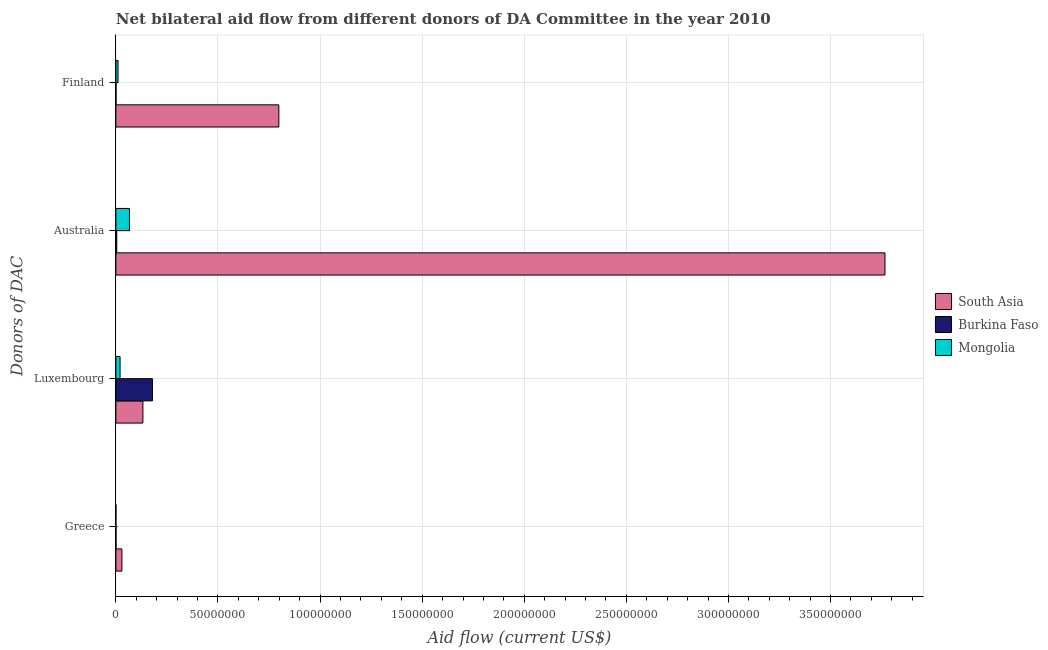How many groups of bars are there?
Provide a succinct answer. 4. Are the number of bars per tick equal to the number of legend labels?
Your answer should be very brief. Yes. How many bars are there on the 4th tick from the top?
Ensure brevity in your answer.  3. How many bars are there on the 1st tick from the bottom?
Keep it short and to the point. 3. What is the label of the 1st group of bars from the top?
Offer a terse response. Finland. What is the amount of aid given by australia in Mongolia?
Provide a succinct answer. 6.64e+06. Across all countries, what is the maximum amount of aid given by finland?
Your answer should be very brief. 7.98e+07. Across all countries, what is the minimum amount of aid given by finland?
Give a very brief answer. 8.00e+04. In which country was the amount of aid given by finland minimum?
Make the answer very short. Burkina Faso. What is the total amount of aid given by greece in the graph?
Make the answer very short. 3.04e+06. What is the difference between the amount of aid given by greece in Burkina Faso and that in Mongolia?
Keep it short and to the point. 6.00e+04. What is the difference between the amount of aid given by finland in Mongolia and the amount of aid given by australia in Burkina Faso?
Provide a succinct answer. 6.40e+05. What is the average amount of aid given by greece per country?
Provide a short and direct response. 1.01e+06. What is the difference between the amount of aid given by greece and amount of aid given by finland in Mongolia?
Make the answer very short. -1.05e+06. What is the ratio of the amount of aid given by luxembourg in Burkina Faso to that in Mongolia?
Provide a short and direct response. 8.73. What is the difference between the highest and the second highest amount of aid given by finland?
Your answer should be very brief. 7.88e+07. What is the difference between the highest and the lowest amount of aid given by greece?
Provide a short and direct response. 2.95e+06. Is the sum of the amount of aid given by finland in Mongolia and South Asia greater than the maximum amount of aid given by greece across all countries?
Your answer should be very brief. Yes. What does the 2nd bar from the top in Greece represents?
Make the answer very short. Burkina Faso. What does the 3rd bar from the bottom in Finland represents?
Give a very brief answer. Mongolia. Are all the bars in the graph horizontal?
Your answer should be compact. Yes. How many countries are there in the graph?
Your answer should be very brief. 3. What is the difference between two consecutive major ticks on the X-axis?
Your answer should be compact. 5.00e+07. Does the graph contain grids?
Keep it short and to the point. Yes. Where does the legend appear in the graph?
Ensure brevity in your answer.  Center right. How many legend labels are there?
Give a very brief answer. 3. What is the title of the graph?
Your answer should be very brief. Net bilateral aid flow from different donors of DA Committee in the year 2010. Does "Lower middle income" appear as one of the legend labels in the graph?
Offer a terse response. No. What is the label or title of the Y-axis?
Your answer should be compact. Donors of DAC. What is the Aid flow (current US$) of South Asia in Greece?
Your response must be concise. 2.96e+06. What is the Aid flow (current US$) in Burkina Faso in Greece?
Provide a succinct answer. 7.00e+04. What is the Aid flow (current US$) of Mongolia in Greece?
Offer a very short reply. 10000. What is the Aid flow (current US$) of South Asia in Luxembourg?
Keep it short and to the point. 1.32e+07. What is the Aid flow (current US$) of Burkina Faso in Luxembourg?
Make the answer very short. 1.79e+07. What is the Aid flow (current US$) in Mongolia in Luxembourg?
Make the answer very short. 2.05e+06. What is the Aid flow (current US$) of South Asia in Australia?
Make the answer very short. 3.77e+08. What is the Aid flow (current US$) in Burkina Faso in Australia?
Offer a very short reply. 4.20e+05. What is the Aid flow (current US$) in Mongolia in Australia?
Keep it short and to the point. 6.64e+06. What is the Aid flow (current US$) of South Asia in Finland?
Give a very brief answer. 7.98e+07. What is the Aid flow (current US$) in Mongolia in Finland?
Keep it short and to the point. 1.06e+06. Across all Donors of DAC, what is the maximum Aid flow (current US$) of South Asia?
Offer a very short reply. 3.77e+08. Across all Donors of DAC, what is the maximum Aid flow (current US$) in Burkina Faso?
Keep it short and to the point. 1.79e+07. Across all Donors of DAC, what is the maximum Aid flow (current US$) in Mongolia?
Your answer should be very brief. 6.64e+06. Across all Donors of DAC, what is the minimum Aid flow (current US$) in South Asia?
Your answer should be compact. 2.96e+06. Across all Donors of DAC, what is the minimum Aid flow (current US$) in Mongolia?
Provide a succinct answer. 10000. What is the total Aid flow (current US$) in South Asia in the graph?
Offer a terse response. 4.73e+08. What is the total Aid flow (current US$) in Burkina Faso in the graph?
Your answer should be compact. 1.85e+07. What is the total Aid flow (current US$) in Mongolia in the graph?
Your response must be concise. 9.76e+06. What is the difference between the Aid flow (current US$) of South Asia in Greece and that in Luxembourg?
Make the answer very short. -1.03e+07. What is the difference between the Aid flow (current US$) in Burkina Faso in Greece and that in Luxembourg?
Give a very brief answer. -1.78e+07. What is the difference between the Aid flow (current US$) in Mongolia in Greece and that in Luxembourg?
Your answer should be very brief. -2.04e+06. What is the difference between the Aid flow (current US$) of South Asia in Greece and that in Australia?
Give a very brief answer. -3.74e+08. What is the difference between the Aid flow (current US$) in Burkina Faso in Greece and that in Australia?
Provide a succinct answer. -3.50e+05. What is the difference between the Aid flow (current US$) in Mongolia in Greece and that in Australia?
Your answer should be very brief. -6.63e+06. What is the difference between the Aid flow (current US$) of South Asia in Greece and that in Finland?
Keep it short and to the point. -7.68e+07. What is the difference between the Aid flow (current US$) of Mongolia in Greece and that in Finland?
Your answer should be compact. -1.05e+06. What is the difference between the Aid flow (current US$) of South Asia in Luxembourg and that in Australia?
Provide a succinct answer. -3.63e+08. What is the difference between the Aid flow (current US$) of Burkina Faso in Luxembourg and that in Australia?
Offer a terse response. 1.75e+07. What is the difference between the Aid flow (current US$) in Mongolia in Luxembourg and that in Australia?
Ensure brevity in your answer.  -4.59e+06. What is the difference between the Aid flow (current US$) of South Asia in Luxembourg and that in Finland?
Give a very brief answer. -6.66e+07. What is the difference between the Aid flow (current US$) in Burkina Faso in Luxembourg and that in Finland?
Offer a terse response. 1.78e+07. What is the difference between the Aid flow (current US$) in Mongolia in Luxembourg and that in Finland?
Your answer should be very brief. 9.90e+05. What is the difference between the Aid flow (current US$) in South Asia in Australia and that in Finland?
Offer a terse response. 2.97e+08. What is the difference between the Aid flow (current US$) in Burkina Faso in Australia and that in Finland?
Keep it short and to the point. 3.40e+05. What is the difference between the Aid flow (current US$) of Mongolia in Australia and that in Finland?
Keep it short and to the point. 5.58e+06. What is the difference between the Aid flow (current US$) in South Asia in Greece and the Aid flow (current US$) in Burkina Faso in Luxembourg?
Keep it short and to the point. -1.49e+07. What is the difference between the Aid flow (current US$) in South Asia in Greece and the Aid flow (current US$) in Mongolia in Luxembourg?
Provide a short and direct response. 9.10e+05. What is the difference between the Aid flow (current US$) of Burkina Faso in Greece and the Aid flow (current US$) of Mongolia in Luxembourg?
Your response must be concise. -1.98e+06. What is the difference between the Aid flow (current US$) of South Asia in Greece and the Aid flow (current US$) of Burkina Faso in Australia?
Your answer should be very brief. 2.54e+06. What is the difference between the Aid flow (current US$) in South Asia in Greece and the Aid flow (current US$) in Mongolia in Australia?
Offer a terse response. -3.68e+06. What is the difference between the Aid flow (current US$) in Burkina Faso in Greece and the Aid flow (current US$) in Mongolia in Australia?
Your response must be concise. -6.57e+06. What is the difference between the Aid flow (current US$) in South Asia in Greece and the Aid flow (current US$) in Burkina Faso in Finland?
Give a very brief answer. 2.88e+06. What is the difference between the Aid flow (current US$) in South Asia in Greece and the Aid flow (current US$) in Mongolia in Finland?
Your answer should be compact. 1.90e+06. What is the difference between the Aid flow (current US$) of Burkina Faso in Greece and the Aid flow (current US$) of Mongolia in Finland?
Make the answer very short. -9.90e+05. What is the difference between the Aid flow (current US$) of South Asia in Luxembourg and the Aid flow (current US$) of Burkina Faso in Australia?
Your answer should be compact. 1.28e+07. What is the difference between the Aid flow (current US$) in South Asia in Luxembourg and the Aid flow (current US$) in Mongolia in Australia?
Your answer should be compact. 6.59e+06. What is the difference between the Aid flow (current US$) in Burkina Faso in Luxembourg and the Aid flow (current US$) in Mongolia in Australia?
Provide a short and direct response. 1.13e+07. What is the difference between the Aid flow (current US$) of South Asia in Luxembourg and the Aid flow (current US$) of Burkina Faso in Finland?
Make the answer very short. 1.32e+07. What is the difference between the Aid flow (current US$) of South Asia in Luxembourg and the Aid flow (current US$) of Mongolia in Finland?
Your answer should be very brief. 1.22e+07. What is the difference between the Aid flow (current US$) in Burkina Faso in Luxembourg and the Aid flow (current US$) in Mongolia in Finland?
Ensure brevity in your answer.  1.68e+07. What is the difference between the Aid flow (current US$) of South Asia in Australia and the Aid flow (current US$) of Burkina Faso in Finland?
Your response must be concise. 3.77e+08. What is the difference between the Aid flow (current US$) of South Asia in Australia and the Aid flow (current US$) of Mongolia in Finland?
Your response must be concise. 3.76e+08. What is the difference between the Aid flow (current US$) of Burkina Faso in Australia and the Aid flow (current US$) of Mongolia in Finland?
Provide a short and direct response. -6.40e+05. What is the average Aid flow (current US$) of South Asia per Donors of DAC?
Your answer should be compact. 1.18e+08. What is the average Aid flow (current US$) in Burkina Faso per Donors of DAC?
Make the answer very short. 4.62e+06. What is the average Aid flow (current US$) of Mongolia per Donors of DAC?
Provide a short and direct response. 2.44e+06. What is the difference between the Aid flow (current US$) of South Asia and Aid flow (current US$) of Burkina Faso in Greece?
Your answer should be very brief. 2.89e+06. What is the difference between the Aid flow (current US$) in South Asia and Aid flow (current US$) in Mongolia in Greece?
Your answer should be compact. 2.95e+06. What is the difference between the Aid flow (current US$) of South Asia and Aid flow (current US$) of Burkina Faso in Luxembourg?
Ensure brevity in your answer.  -4.67e+06. What is the difference between the Aid flow (current US$) of South Asia and Aid flow (current US$) of Mongolia in Luxembourg?
Ensure brevity in your answer.  1.12e+07. What is the difference between the Aid flow (current US$) in Burkina Faso and Aid flow (current US$) in Mongolia in Luxembourg?
Give a very brief answer. 1.58e+07. What is the difference between the Aid flow (current US$) of South Asia and Aid flow (current US$) of Burkina Faso in Australia?
Your answer should be compact. 3.76e+08. What is the difference between the Aid flow (current US$) in South Asia and Aid flow (current US$) in Mongolia in Australia?
Give a very brief answer. 3.70e+08. What is the difference between the Aid flow (current US$) of Burkina Faso and Aid flow (current US$) of Mongolia in Australia?
Offer a very short reply. -6.22e+06. What is the difference between the Aid flow (current US$) in South Asia and Aid flow (current US$) in Burkina Faso in Finland?
Provide a succinct answer. 7.97e+07. What is the difference between the Aid flow (current US$) in South Asia and Aid flow (current US$) in Mongolia in Finland?
Provide a short and direct response. 7.88e+07. What is the difference between the Aid flow (current US$) in Burkina Faso and Aid flow (current US$) in Mongolia in Finland?
Offer a terse response. -9.80e+05. What is the ratio of the Aid flow (current US$) of South Asia in Greece to that in Luxembourg?
Offer a terse response. 0.22. What is the ratio of the Aid flow (current US$) of Burkina Faso in Greece to that in Luxembourg?
Provide a short and direct response. 0. What is the ratio of the Aid flow (current US$) of Mongolia in Greece to that in Luxembourg?
Your response must be concise. 0. What is the ratio of the Aid flow (current US$) of South Asia in Greece to that in Australia?
Keep it short and to the point. 0.01. What is the ratio of the Aid flow (current US$) in Burkina Faso in Greece to that in Australia?
Provide a succinct answer. 0.17. What is the ratio of the Aid flow (current US$) of Mongolia in Greece to that in Australia?
Offer a terse response. 0. What is the ratio of the Aid flow (current US$) in South Asia in Greece to that in Finland?
Give a very brief answer. 0.04. What is the ratio of the Aid flow (current US$) of Burkina Faso in Greece to that in Finland?
Offer a very short reply. 0.88. What is the ratio of the Aid flow (current US$) of Mongolia in Greece to that in Finland?
Make the answer very short. 0.01. What is the ratio of the Aid flow (current US$) of South Asia in Luxembourg to that in Australia?
Provide a succinct answer. 0.04. What is the ratio of the Aid flow (current US$) of Burkina Faso in Luxembourg to that in Australia?
Your answer should be compact. 42.62. What is the ratio of the Aid flow (current US$) in Mongolia in Luxembourg to that in Australia?
Provide a succinct answer. 0.31. What is the ratio of the Aid flow (current US$) in South Asia in Luxembourg to that in Finland?
Your answer should be very brief. 0.17. What is the ratio of the Aid flow (current US$) in Burkina Faso in Luxembourg to that in Finland?
Keep it short and to the point. 223.75. What is the ratio of the Aid flow (current US$) in Mongolia in Luxembourg to that in Finland?
Your answer should be very brief. 1.93. What is the ratio of the Aid flow (current US$) in South Asia in Australia to that in Finland?
Ensure brevity in your answer.  4.72. What is the ratio of the Aid flow (current US$) in Burkina Faso in Australia to that in Finland?
Your answer should be very brief. 5.25. What is the ratio of the Aid flow (current US$) of Mongolia in Australia to that in Finland?
Keep it short and to the point. 6.26. What is the difference between the highest and the second highest Aid flow (current US$) in South Asia?
Provide a succinct answer. 2.97e+08. What is the difference between the highest and the second highest Aid flow (current US$) of Burkina Faso?
Your answer should be very brief. 1.75e+07. What is the difference between the highest and the second highest Aid flow (current US$) in Mongolia?
Provide a short and direct response. 4.59e+06. What is the difference between the highest and the lowest Aid flow (current US$) of South Asia?
Your answer should be compact. 3.74e+08. What is the difference between the highest and the lowest Aid flow (current US$) of Burkina Faso?
Your answer should be very brief. 1.78e+07. What is the difference between the highest and the lowest Aid flow (current US$) in Mongolia?
Make the answer very short. 6.63e+06. 